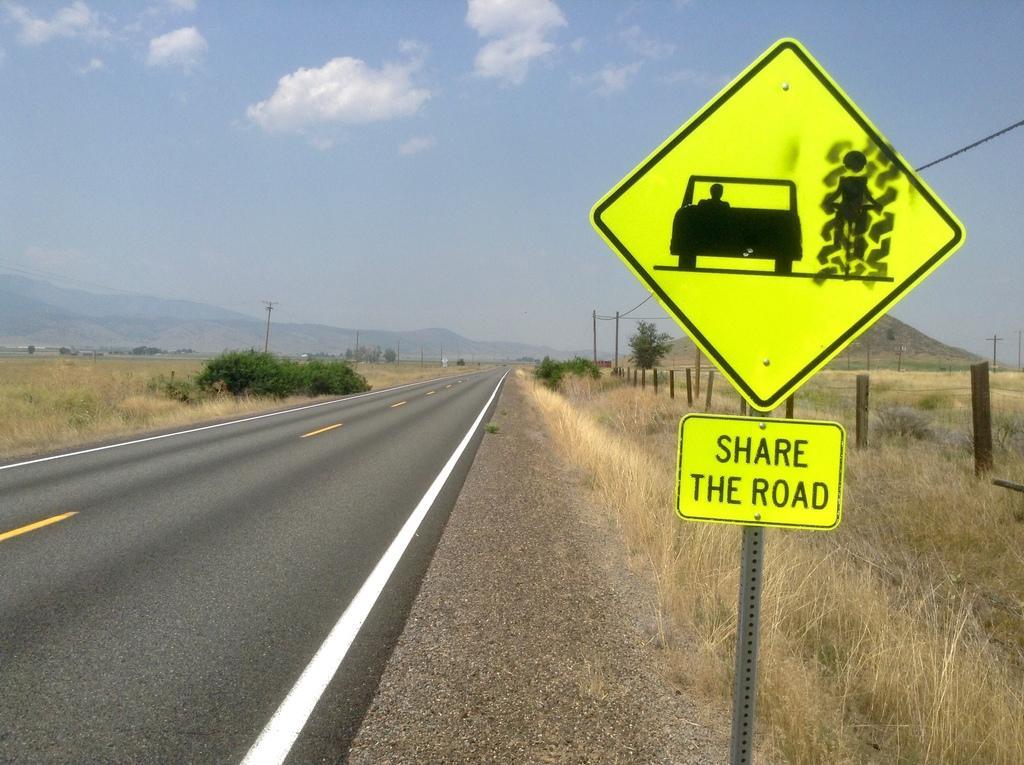Describe this image in one or two sentences. In this image in the front there is a board with some text and symbols on it. In the background there is dry grass, there are plants, poles and there are mountains and the sky is cloudy. 